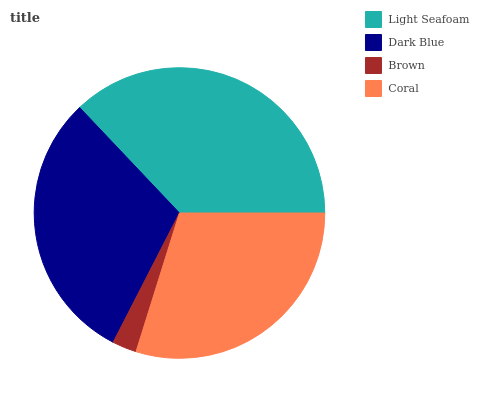Is Brown the minimum?
Answer yes or no. Yes. Is Light Seafoam the maximum?
Answer yes or no. Yes. Is Dark Blue the minimum?
Answer yes or no. No. Is Dark Blue the maximum?
Answer yes or no. No. Is Light Seafoam greater than Dark Blue?
Answer yes or no. Yes. Is Dark Blue less than Light Seafoam?
Answer yes or no. Yes. Is Dark Blue greater than Light Seafoam?
Answer yes or no. No. Is Light Seafoam less than Dark Blue?
Answer yes or no. No. Is Dark Blue the high median?
Answer yes or no. Yes. Is Coral the low median?
Answer yes or no. Yes. Is Brown the high median?
Answer yes or no. No. Is Dark Blue the low median?
Answer yes or no. No. 